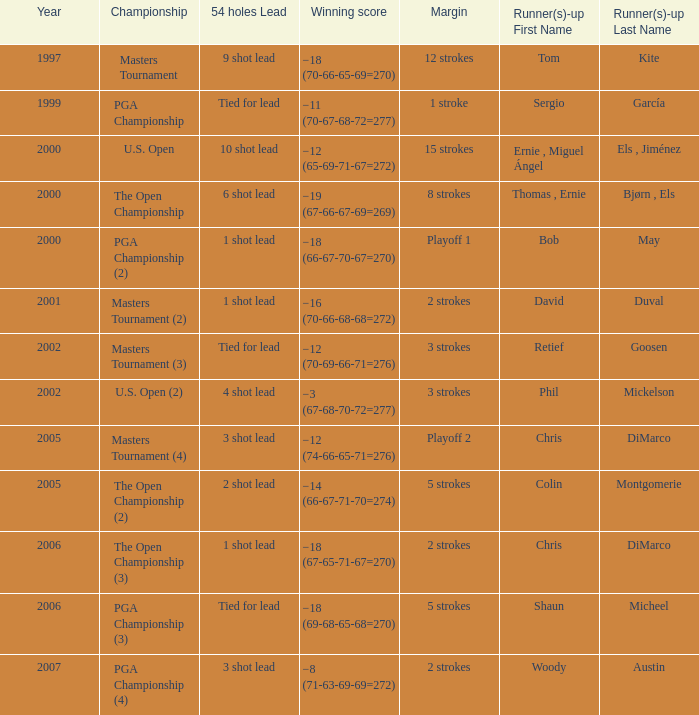 what's the championship where 54 holes is 1 shot lead and runner(s)-up is chris dimarco The Open Championship (3). 